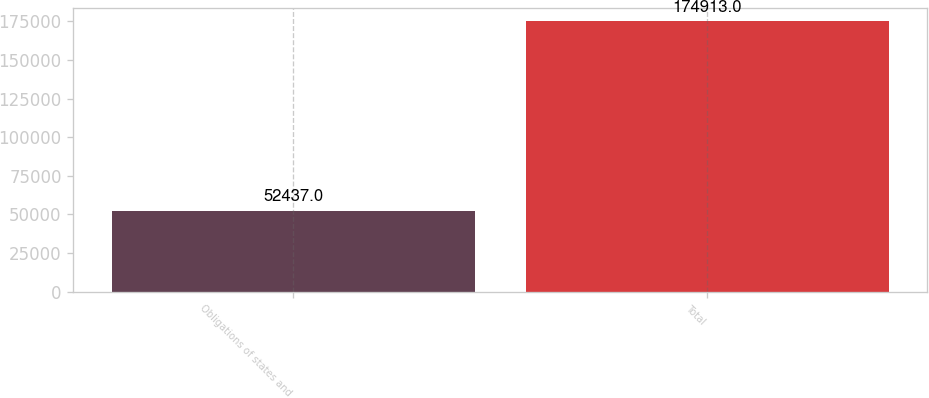Convert chart. <chart><loc_0><loc_0><loc_500><loc_500><bar_chart><fcel>Obligations of states and<fcel>Total<nl><fcel>52437<fcel>174913<nl></chart> 